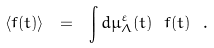Convert formula to latex. <formula><loc_0><loc_0><loc_500><loc_500>\langle f ( t ) \rangle \ = \ \int d \mu ^ { \varepsilon } _ { \Lambda } ( t ) \ f ( t ) \ .</formula> 